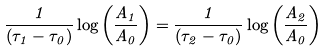<formula> <loc_0><loc_0><loc_500><loc_500>\frac { 1 } { ( \tau _ { 1 } - \tau _ { 0 } ) } \log \left ( \frac { A _ { 1 } } { A _ { 0 } } \right ) = \frac { 1 } { ( \tau _ { 2 } - \tau _ { 0 } ) } \log \left ( \frac { A _ { 2 } } { A _ { 0 } } \right )</formula> 